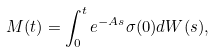<formula> <loc_0><loc_0><loc_500><loc_500>M ( t ) = \int _ { 0 } ^ { t } e ^ { - A s } \sigma ( 0 ) d W ( s ) ,</formula> 